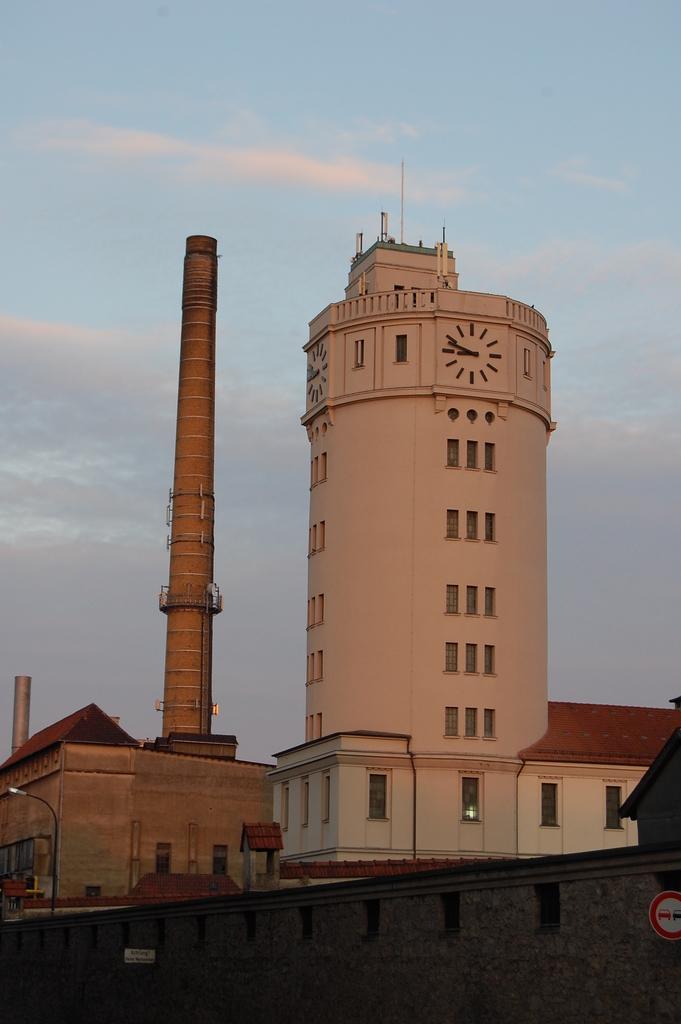In one or two sentences, can you explain what this image depicts? In this image there are buildings and lamp posts, in front of the image there is a sign board on the wall. 